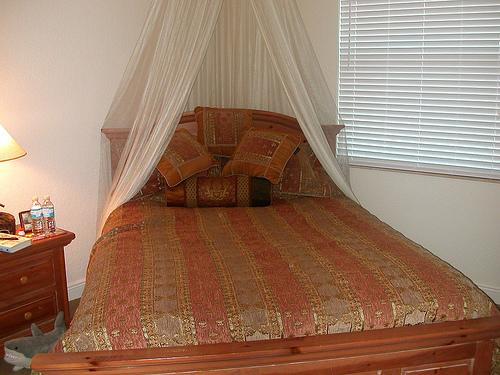Identify the primary pieces of furniture in the image along with their accessories. A wood bed in the bedroom with a mosquito net over it, orange and brown throw pillows and comforter, an oak nightstand beside it with a lamp, and a book. State the abstract theme that involves the furniture in the image. A cozy bedroom featuring wooden furniture, warm-toned bedding, and functional accessories. Briefly point out the objects resting on the nightstand in the image. The nightstand has a lamp, two bottles of water, and a closed book on it. Talk about the set pieces related to hydration in the image. There are two clear water bottles on the night stand next to the bed, as well as two bottles of generic filtered water. Briefly describe any toys or stuffed animals in the image. Stuffed whale and a shark pillow are seen on the floor of the bedroom. Mention the window dressing in the image. In the image, the window has closed plain white blinds and a pair of white blinds near the bed. Mention the type of bed and any covering it has in the image. An oak bed frame is positioned in the room corner with a sheer white canopy covering the bed. Describe the bedding and pillows present in the image. The bed has a white canopy, orange and tan bedspread, orange and brown detailed comforter, circular pillow, three square pillows, and orange and brown throw pillows. In the image, describe the comforter on the bed and any unique colors or patterns. The comforter on the bed is orange and brown, with intricate detailing. List the objects in the room related to illumination. There's a white lamp shade on the nightstand with a lit bulb inside. 